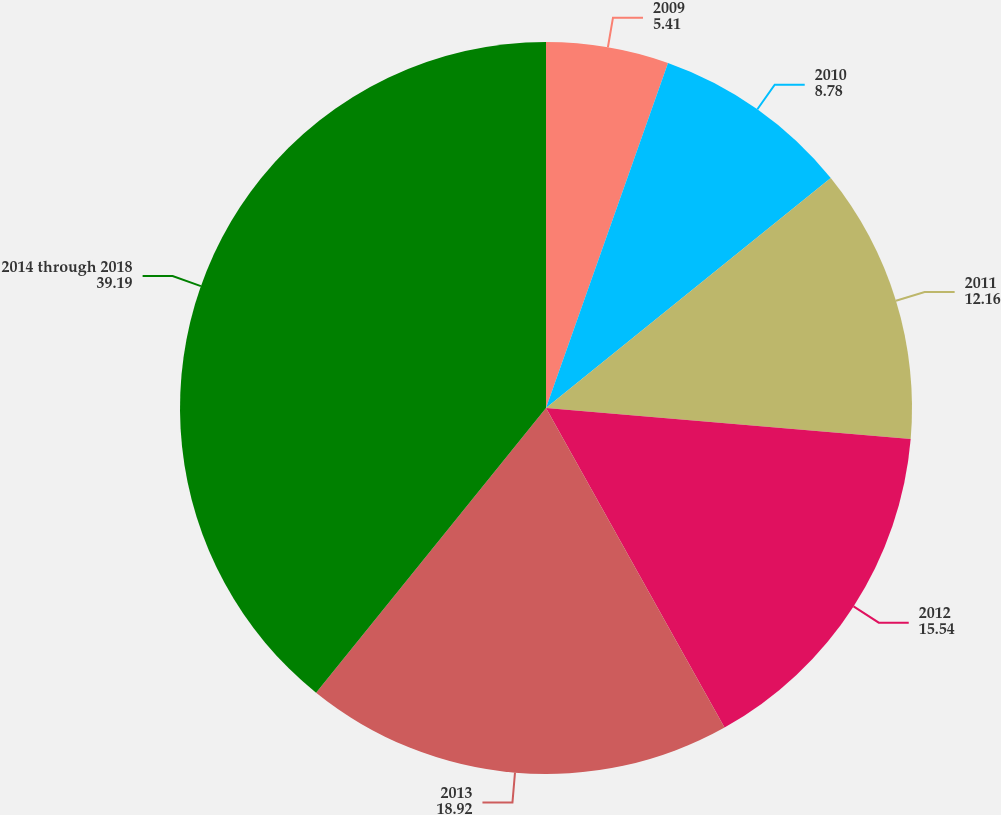Convert chart to OTSL. <chart><loc_0><loc_0><loc_500><loc_500><pie_chart><fcel>2009<fcel>2010<fcel>2011<fcel>2012<fcel>2013<fcel>2014 through 2018<nl><fcel>5.41%<fcel>8.78%<fcel>12.16%<fcel>15.54%<fcel>18.92%<fcel>39.19%<nl></chart> 